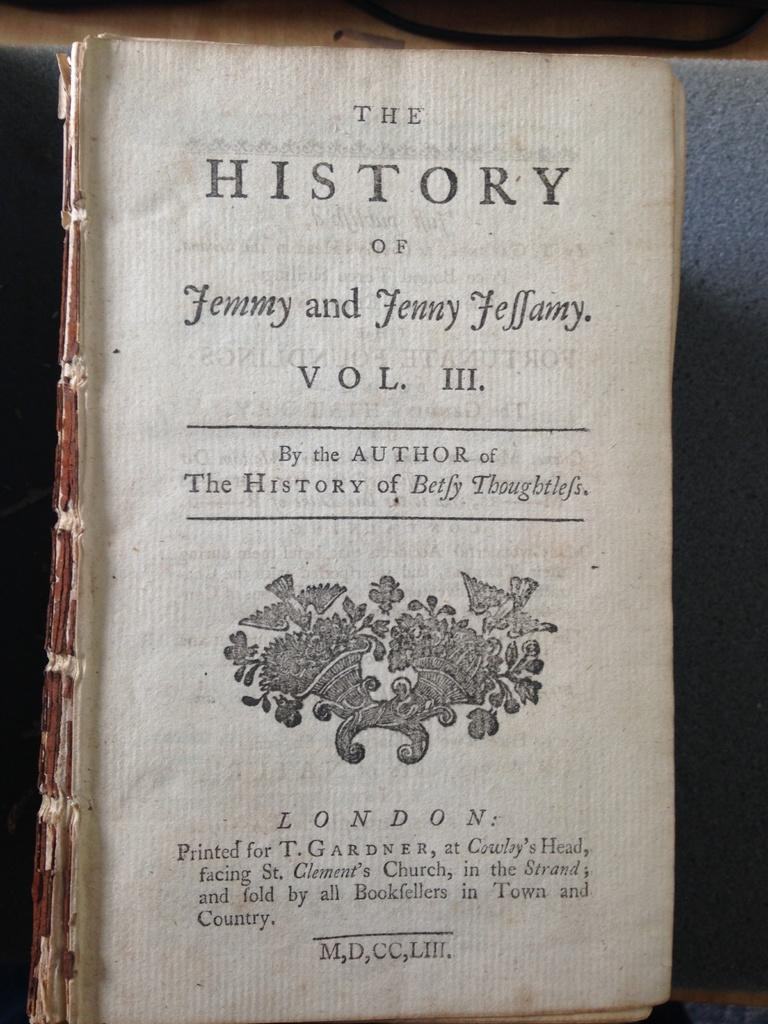<image>
Share a concise interpretation of the image provided. A fraying old book without a cover says The History of Jemmy and Jenny Feffamy. 